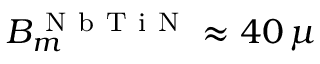Convert formula to latex. <formula><loc_0><loc_0><loc_500><loc_500>B _ { m } ^ { N b T i N } \approx 4 0 \, \mu</formula> 